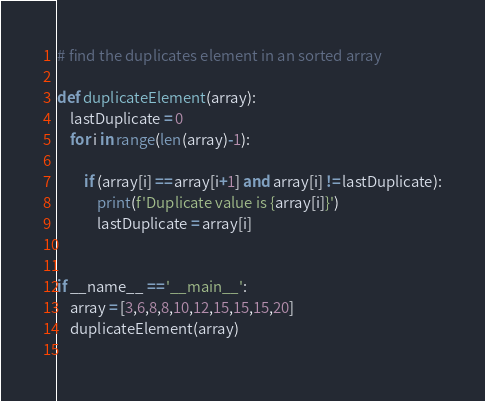Convert code to text. <code><loc_0><loc_0><loc_500><loc_500><_Python_># find the duplicates element in an sorted array

def duplicateElement(array):
	lastDuplicate = 0
	for i in range(len(array)-1):

		if (array[i] == array[i+1] and array[i] != lastDuplicate):
			print(f'Duplicate value is {array[i]}')
			lastDuplicate = array[i]


if __name__ == '__main__':
	array = [3,6,8,8,10,12,15,15,15,20]
	duplicateElement(array)
	
</code> 